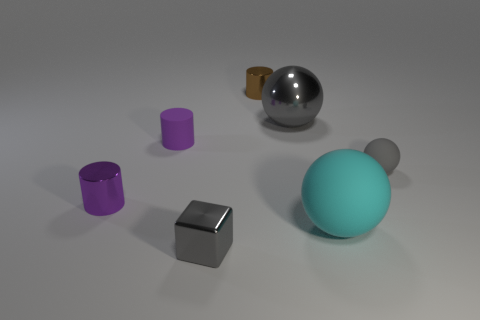What might be the function of these objects if they were part of a larger machine? If these objects were part of a larger machine, the spheres could be bearings or pivots, the cylinders might serve as spacers or rollers, and the gray prism might be a structural component or a connector. Their simple geometric shapes suggest they might fit together in a modular system or facilitate movement in a mechanical assembly. 